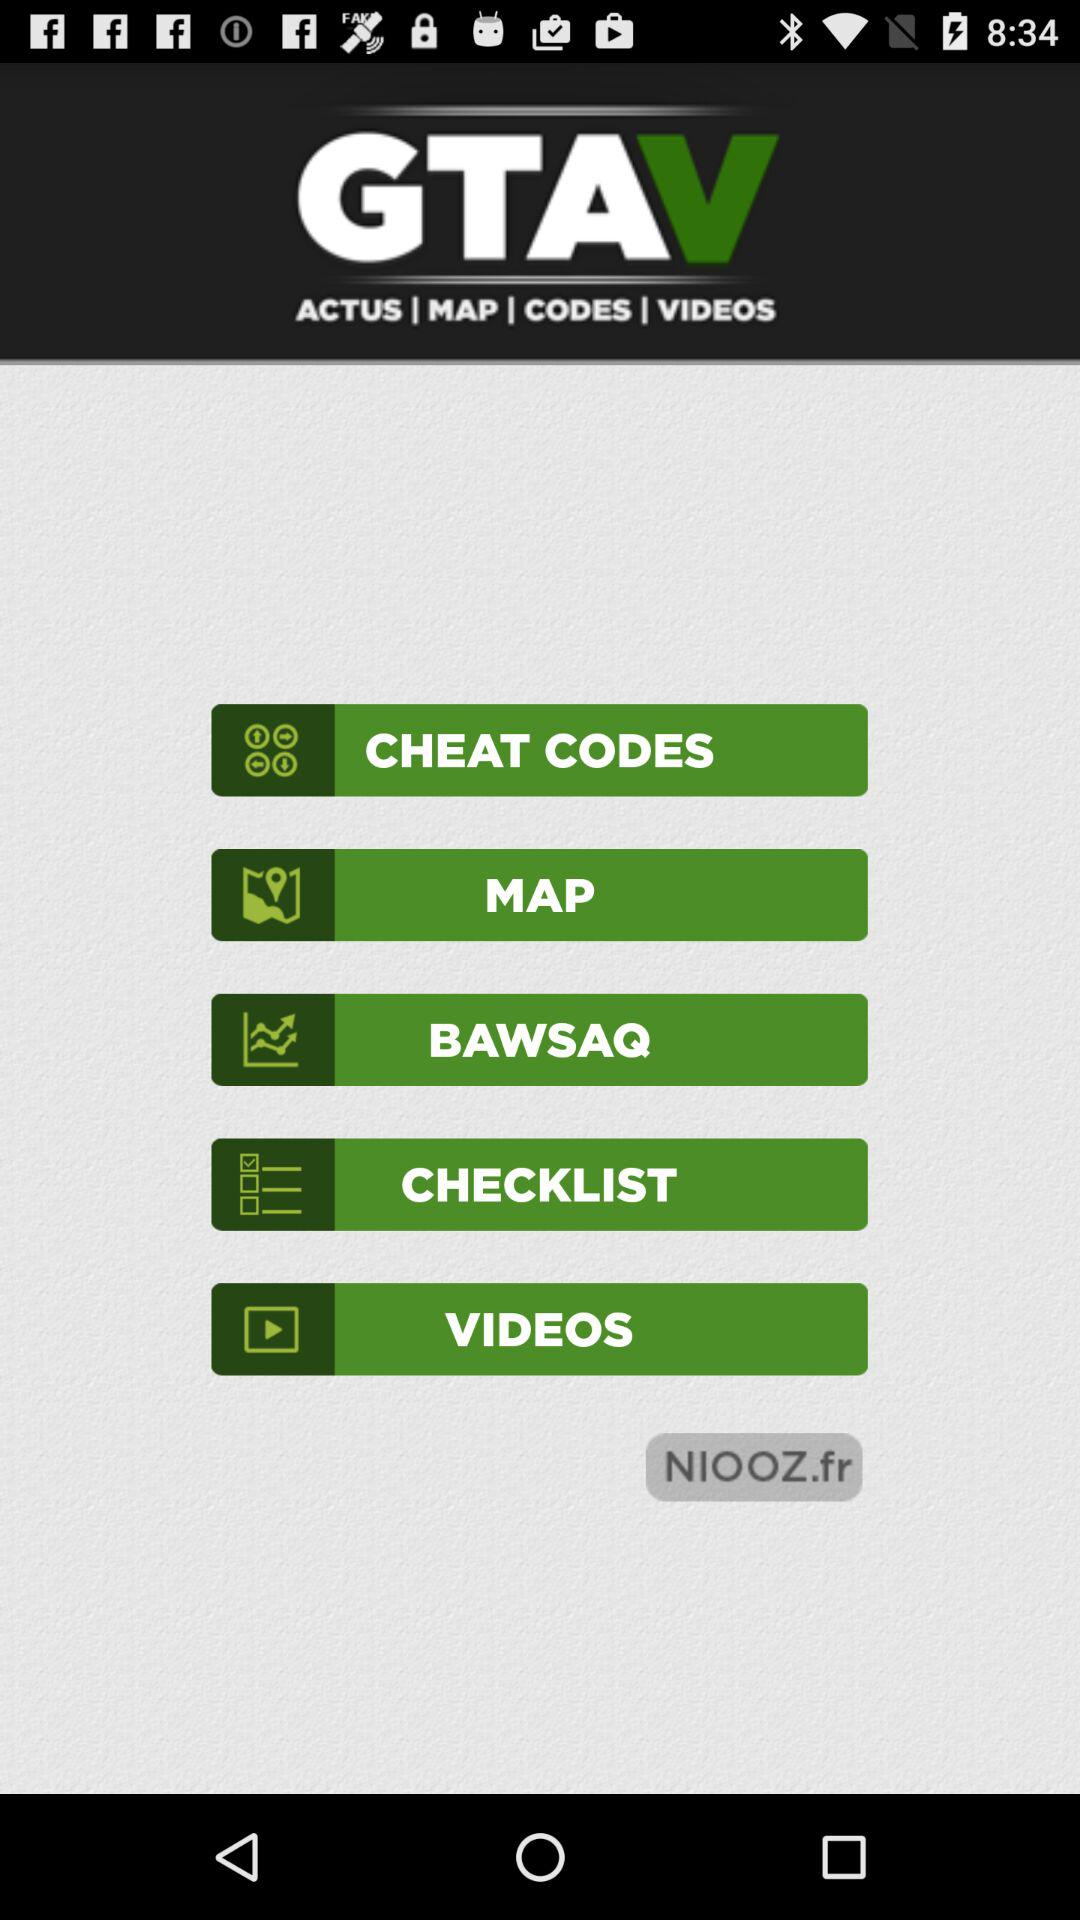What is the name of the application? The name of the application is "GTAV". 